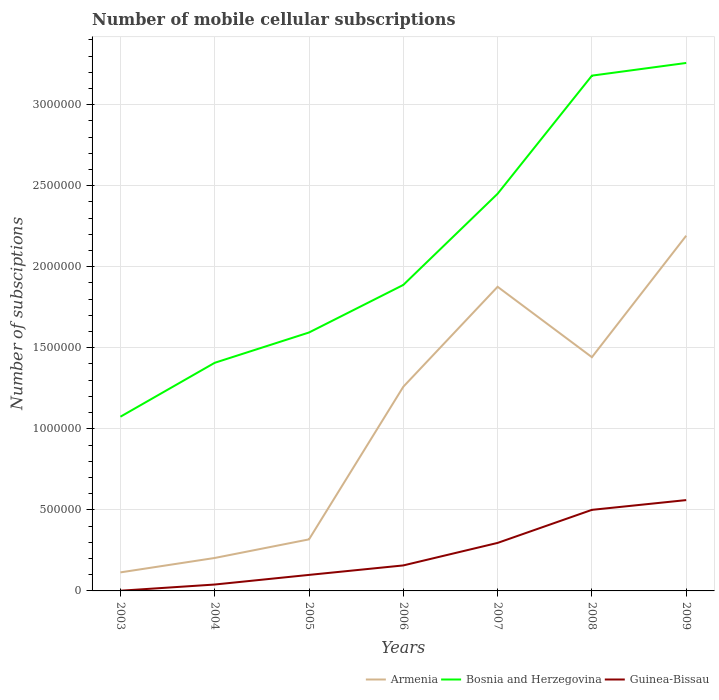How many different coloured lines are there?
Your response must be concise. 3. Does the line corresponding to Armenia intersect with the line corresponding to Guinea-Bissau?
Offer a terse response. No. Across all years, what is the maximum number of mobile cellular subscriptions in Bosnia and Herzegovina?
Your answer should be very brief. 1.07e+06. In which year was the number of mobile cellular subscriptions in Guinea-Bissau maximum?
Give a very brief answer. 2003. What is the total number of mobile cellular subscriptions in Bosnia and Herzegovina in the graph?
Ensure brevity in your answer.  -8.13e+05. What is the difference between the highest and the second highest number of mobile cellular subscriptions in Armenia?
Your response must be concise. 2.08e+06. What is the difference between two consecutive major ticks on the Y-axis?
Your response must be concise. 5.00e+05. Are the values on the major ticks of Y-axis written in scientific E-notation?
Your answer should be very brief. No. Does the graph contain any zero values?
Your answer should be compact. No. Where does the legend appear in the graph?
Keep it short and to the point. Bottom right. What is the title of the graph?
Keep it short and to the point. Number of mobile cellular subscriptions. Does "San Marino" appear as one of the legend labels in the graph?
Your answer should be very brief. No. What is the label or title of the Y-axis?
Provide a succinct answer. Number of subsciptions. What is the Number of subsciptions in Armenia in 2003?
Your answer should be very brief. 1.14e+05. What is the Number of subsciptions in Bosnia and Herzegovina in 2003?
Offer a terse response. 1.07e+06. What is the Number of subsciptions of Guinea-Bissau in 2003?
Provide a succinct answer. 1275. What is the Number of subsciptions in Armenia in 2004?
Offer a very short reply. 2.03e+05. What is the Number of subsciptions in Bosnia and Herzegovina in 2004?
Your answer should be very brief. 1.41e+06. What is the Number of subsciptions in Guinea-Bissau in 2004?
Your answer should be compact. 3.95e+04. What is the Number of subsciptions of Armenia in 2005?
Your answer should be very brief. 3.18e+05. What is the Number of subsciptions of Bosnia and Herzegovina in 2005?
Offer a terse response. 1.59e+06. What is the Number of subsciptions of Guinea-Bissau in 2005?
Make the answer very short. 9.88e+04. What is the Number of subsciptions in Armenia in 2006?
Provide a succinct answer. 1.26e+06. What is the Number of subsciptions of Bosnia and Herzegovina in 2006?
Offer a terse response. 1.89e+06. What is the Number of subsciptions in Guinea-Bissau in 2006?
Ensure brevity in your answer.  1.57e+05. What is the Number of subsciptions of Armenia in 2007?
Your response must be concise. 1.88e+06. What is the Number of subsciptions in Bosnia and Herzegovina in 2007?
Make the answer very short. 2.45e+06. What is the Number of subsciptions of Guinea-Bissau in 2007?
Provide a short and direct response. 2.96e+05. What is the Number of subsciptions of Armenia in 2008?
Provide a short and direct response. 1.44e+06. What is the Number of subsciptions in Bosnia and Herzegovina in 2008?
Provide a succinct answer. 3.18e+06. What is the Number of subsciptions of Guinea-Bissau in 2008?
Your answer should be very brief. 5.00e+05. What is the Number of subsciptions in Armenia in 2009?
Offer a terse response. 2.19e+06. What is the Number of subsciptions of Bosnia and Herzegovina in 2009?
Offer a terse response. 3.26e+06. What is the Number of subsciptions in Guinea-Bissau in 2009?
Provide a succinct answer. 5.60e+05. Across all years, what is the maximum Number of subsciptions of Armenia?
Offer a terse response. 2.19e+06. Across all years, what is the maximum Number of subsciptions in Bosnia and Herzegovina?
Provide a succinct answer. 3.26e+06. Across all years, what is the maximum Number of subsciptions in Guinea-Bissau?
Give a very brief answer. 5.60e+05. Across all years, what is the minimum Number of subsciptions in Armenia?
Your response must be concise. 1.14e+05. Across all years, what is the minimum Number of subsciptions in Bosnia and Herzegovina?
Give a very brief answer. 1.07e+06. Across all years, what is the minimum Number of subsciptions of Guinea-Bissau?
Provide a succinct answer. 1275. What is the total Number of subsciptions of Armenia in the graph?
Your answer should be compact. 7.41e+06. What is the total Number of subsciptions in Bosnia and Herzegovina in the graph?
Your response must be concise. 1.49e+07. What is the total Number of subsciptions of Guinea-Bissau in the graph?
Offer a terse response. 1.65e+06. What is the difference between the Number of subsciptions in Armenia in 2003 and that in 2004?
Your answer should be compact. -8.89e+04. What is the difference between the Number of subsciptions in Bosnia and Herzegovina in 2003 and that in 2004?
Your answer should be compact. -3.33e+05. What is the difference between the Number of subsciptions of Guinea-Bissau in 2003 and that in 2004?
Offer a very short reply. -3.82e+04. What is the difference between the Number of subsciptions in Armenia in 2003 and that in 2005?
Offer a very short reply. -2.04e+05. What is the difference between the Number of subsciptions in Bosnia and Herzegovina in 2003 and that in 2005?
Keep it short and to the point. -5.20e+05. What is the difference between the Number of subsciptions in Guinea-Bissau in 2003 and that in 2005?
Your response must be concise. -9.76e+04. What is the difference between the Number of subsciptions in Armenia in 2003 and that in 2006?
Give a very brief answer. -1.15e+06. What is the difference between the Number of subsciptions of Bosnia and Herzegovina in 2003 and that in 2006?
Offer a very short reply. -8.13e+05. What is the difference between the Number of subsciptions in Guinea-Bissau in 2003 and that in 2006?
Provide a short and direct response. -1.56e+05. What is the difference between the Number of subsciptions of Armenia in 2003 and that in 2007?
Offer a very short reply. -1.76e+06. What is the difference between the Number of subsciptions of Bosnia and Herzegovina in 2003 and that in 2007?
Provide a short and direct response. -1.38e+06. What is the difference between the Number of subsciptions of Guinea-Bissau in 2003 and that in 2007?
Your response must be concise. -2.95e+05. What is the difference between the Number of subsciptions of Armenia in 2003 and that in 2008?
Provide a succinct answer. -1.33e+06. What is the difference between the Number of subsciptions in Bosnia and Herzegovina in 2003 and that in 2008?
Make the answer very short. -2.10e+06. What is the difference between the Number of subsciptions of Guinea-Bissau in 2003 and that in 2008?
Offer a very short reply. -4.99e+05. What is the difference between the Number of subsciptions of Armenia in 2003 and that in 2009?
Keep it short and to the point. -2.08e+06. What is the difference between the Number of subsciptions of Bosnia and Herzegovina in 2003 and that in 2009?
Your answer should be compact. -2.18e+06. What is the difference between the Number of subsciptions in Guinea-Bissau in 2003 and that in 2009?
Ensure brevity in your answer.  -5.59e+05. What is the difference between the Number of subsciptions in Armenia in 2004 and that in 2005?
Your answer should be compact. -1.15e+05. What is the difference between the Number of subsciptions in Bosnia and Herzegovina in 2004 and that in 2005?
Keep it short and to the point. -1.87e+05. What is the difference between the Number of subsciptions of Guinea-Bissau in 2004 and that in 2005?
Offer a very short reply. -5.94e+04. What is the difference between the Number of subsciptions in Armenia in 2004 and that in 2006?
Provide a short and direct response. -1.06e+06. What is the difference between the Number of subsciptions of Bosnia and Herzegovina in 2004 and that in 2006?
Your answer should be compact. -4.80e+05. What is the difference between the Number of subsciptions of Guinea-Bissau in 2004 and that in 2006?
Provide a short and direct response. -1.18e+05. What is the difference between the Number of subsciptions in Armenia in 2004 and that in 2007?
Your response must be concise. -1.67e+06. What is the difference between the Number of subsciptions of Bosnia and Herzegovina in 2004 and that in 2007?
Offer a very short reply. -1.04e+06. What is the difference between the Number of subsciptions of Guinea-Bissau in 2004 and that in 2007?
Offer a terse response. -2.57e+05. What is the difference between the Number of subsciptions of Armenia in 2004 and that in 2008?
Your response must be concise. -1.24e+06. What is the difference between the Number of subsciptions in Bosnia and Herzegovina in 2004 and that in 2008?
Make the answer very short. -1.77e+06. What is the difference between the Number of subsciptions of Guinea-Bissau in 2004 and that in 2008?
Provide a succinct answer. -4.61e+05. What is the difference between the Number of subsciptions of Armenia in 2004 and that in 2009?
Your response must be concise. -1.99e+06. What is the difference between the Number of subsciptions of Bosnia and Herzegovina in 2004 and that in 2009?
Give a very brief answer. -1.85e+06. What is the difference between the Number of subsciptions of Guinea-Bissau in 2004 and that in 2009?
Give a very brief answer. -5.21e+05. What is the difference between the Number of subsciptions in Armenia in 2005 and that in 2006?
Provide a short and direct response. -9.42e+05. What is the difference between the Number of subsciptions of Bosnia and Herzegovina in 2005 and that in 2006?
Your answer should be very brief. -2.93e+05. What is the difference between the Number of subsciptions of Guinea-Bissau in 2005 and that in 2006?
Your answer should be compact. -5.85e+04. What is the difference between the Number of subsciptions of Armenia in 2005 and that in 2007?
Your answer should be compact. -1.56e+06. What is the difference between the Number of subsciptions of Bosnia and Herzegovina in 2005 and that in 2007?
Your response must be concise. -8.56e+05. What is the difference between the Number of subsciptions of Guinea-Bissau in 2005 and that in 2007?
Offer a very short reply. -1.97e+05. What is the difference between the Number of subsciptions in Armenia in 2005 and that in 2008?
Ensure brevity in your answer.  -1.12e+06. What is the difference between the Number of subsciptions of Bosnia and Herzegovina in 2005 and that in 2008?
Ensure brevity in your answer.  -1.58e+06. What is the difference between the Number of subsciptions of Guinea-Bissau in 2005 and that in 2008?
Make the answer very short. -4.01e+05. What is the difference between the Number of subsciptions of Armenia in 2005 and that in 2009?
Provide a short and direct response. -1.87e+06. What is the difference between the Number of subsciptions of Bosnia and Herzegovina in 2005 and that in 2009?
Ensure brevity in your answer.  -1.66e+06. What is the difference between the Number of subsciptions in Guinea-Bissau in 2005 and that in 2009?
Keep it short and to the point. -4.62e+05. What is the difference between the Number of subsciptions in Armenia in 2006 and that in 2007?
Offer a terse response. -6.17e+05. What is the difference between the Number of subsciptions of Bosnia and Herzegovina in 2006 and that in 2007?
Provide a short and direct response. -5.63e+05. What is the difference between the Number of subsciptions in Guinea-Bissau in 2006 and that in 2007?
Provide a short and direct response. -1.39e+05. What is the difference between the Number of subsciptions in Armenia in 2006 and that in 2008?
Your answer should be very brief. -1.82e+05. What is the difference between the Number of subsciptions of Bosnia and Herzegovina in 2006 and that in 2008?
Offer a terse response. -1.29e+06. What is the difference between the Number of subsciptions of Guinea-Bissau in 2006 and that in 2008?
Offer a terse response. -3.43e+05. What is the difference between the Number of subsciptions in Armenia in 2006 and that in 2009?
Offer a terse response. -9.32e+05. What is the difference between the Number of subsciptions of Bosnia and Herzegovina in 2006 and that in 2009?
Give a very brief answer. -1.37e+06. What is the difference between the Number of subsciptions in Guinea-Bissau in 2006 and that in 2009?
Keep it short and to the point. -4.03e+05. What is the difference between the Number of subsciptions of Armenia in 2007 and that in 2008?
Keep it short and to the point. 4.34e+05. What is the difference between the Number of subsciptions in Bosnia and Herzegovina in 2007 and that in 2008?
Provide a succinct answer. -7.29e+05. What is the difference between the Number of subsciptions of Guinea-Bissau in 2007 and that in 2008?
Make the answer very short. -2.04e+05. What is the difference between the Number of subsciptions in Armenia in 2007 and that in 2009?
Offer a terse response. -3.15e+05. What is the difference between the Number of subsciptions of Bosnia and Herzegovina in 2007 and that in 2009?
Keep it short and to the point. -8.07e+05. What is the difference between the Number of subsciptions in Guinea-Bissau in 2007 and that in 2009?
Your response must be concise. -2.64e+05. What is the difference between the Number of subsciptions of Armenia in 2008 and that in 2009?
Make the answer very short. -7.50e+05. What is the difference between the Number of subsciptions in Bosnia and Herzegovina in 2008 and that in 2009?
Provide a succinct answer. -7.82e+04. What is the difference between the Number of subsciptions in Guinea-Bissau in 2008 and that in 2009?
Ensure brevity in your answer.  -6.02e+04. What is the difference between the Number of subsciptions in Armenia in 2003 and the Number of subsciptions in Bosnia and Herzegovina in 2004?
Provide a short and direct response. -1.29e+06. What is the difference between the Number of subsciptions of Armenia in 2003 and the Number of subsciptions of Guinea-Bissau in 2004?
Provide a succinct answer. 7.49e+04. What is the difference between the Number of subsciptions in Bosnia and Herzegovina in 2003 and the Number of subsciptions in Guinea-Bissau in 2004?
Offer a terse response. 1.04e+06. What is the difference between the Number of subsciptions in Armenia in 2003 and the Number of subsciptions in Bosnia and Herzegovina in 2005?
Your answer should be compact. -1.48e+06. What is the difference between the Number of subsciptions of Armenia in 2003 and the Number of subsciptions of Guinea-Bissau in 2005?
Make the answer very short. 1.56e+04. What is the difference between the Number of subsciptions in Bosnia and Herzegovina in 2003 and the Number of subsciptions in Guinea-Bissau in 2005?
Give a very brief answer. 9.76e+05. What is the difference between the Number of subsciptions in Armenia in 2003 and the Number of subsciptions in Bosnia and Herzegovina in 2006?
Offer a terse response. -1.77e+06. What is the difference between the Number of subsciptions in Armenia in 2003 and the Number of subsciptions in Guinea-Bissau in 2006?
Your answer should be compact. -4.30e+04. What is the difference between the Number of subsciptions of Bosnia and Herzegovina in 2003 and the Number of subsciptions of Guinea-Bissau in 2006?
Keep it short and to the point. 9.17e+05. What is the difference between the Number of subsciptions in Armenia in 2003 and the Number of subsciptions in Bosnia and Herzegovina in 2007?
Provide a succinct answer. -2.34e+06. What is the difference between the Number of subsciptions in Armenia in 2003 and the Number of subsciptions in Guinea-Bissau in 2007?
Your answer should be very brief. -1.82e+05. What is the difference between the Number of subsciptions of Bosnia and Herzegovina in 2003 and the Number of subsciptions of Guinea-Bissau in 2007?
Provide a short and direct response. 7.79e+05. What is the difference between the Number of subsciptions in Armenia in 2003 and the Number of subsciptions in Bosnia and Herzegovina in 2008?
Offer a terse response. -3.06e+06. What is the difference between the Number of subsciptions in Armenia in 2003 and the Number of subsciptions in Guinea-Bissau in 2008?
Provide a short and direct response. -3.86e+05. What is the difference between the Number of subsciptions of Bosnia and Herzegovina in 2003 and the Number of subsciptions of Guinea-Bissau in 2008?
Give a very brief answer. 5.75e+05. What is the difference between the Number of subsciptions of Armenia in 2003 and the Number of subsciptions of Bosnia and Herzegovina in 2009?
Ensure brevity in your answer.  -3.14e+06. What is the difference between the Number of subsciptions in Armenia in 2003 and the Number of subsciptions in Guinea-Bissau in 2009?
Make the answer very short. -4.46e+05. What is the difference between the Number of subsciptions in Bosnia and Herzegovina in 2003 and the Number of subsciptions in Guinea-Bissau in 2009?
Your answer should be very brief. 5.14e+05. What is the difference between the Number of subsciptions in Armenia in 2004 and the Number of subsciptions in Bosnia and Herzegovina in 2005?
Give a very brief answer. -1.39e+06. What is the difference between the Number of subsciptions of Armenia in 2004 and the Number of subsciptions of Guinea-Bissau in 2005?
Your answer should be compact. 1.04e+05. What is the difference between the Number of subsciptions in Bosnia and Herzegovina in 2004 and the Number of subsciptions in Guinea-Bissau in 2005?
Your answer should be very brief. 1.31e+06. What is the difference between the Number of subsciptions of Armenia in 2004 and the Number of subsciptions of Bosnia and Herzegovina in 2006?
Your answer should be very brief. -1.68e+06. What is the difference between the Number of subsciptions in Armenia in 2004 and the Number of subsciptions in Guinea-Bissau in 2006?
Provide a short and direct response. 4.60e+04. What is the difference between the Number of subsciptions in Bosnia and Herzegovina in 2004 and the Number of subsciptions in Guinea-Bissau in 2006?
Offer a terse response. 1.25e+06. What is the difference between the Number of subsciptions of Armenia in 2004 and the Number of subsciptions of Bosnia and Herzegovina in 2007?
Keep it short and to the point. -2.25e+06. What is the difference between the Number of subsciptions of Armenia in 2004 and the Number of subsciptions of Guinea-Bissau in 2007?
Ensure brevity in your answer.  -9.29e+04. What is the difference between the Number of subsciptions in Bosnia and Herzegovina in 2004 and the Number of subsciptions in Guinea-Bissau in 2007?
Keep it short and to the point. 1.11e+06. What is the difference between the Number of subsciptions in Armenia in 2004 and the Number of subsciptions in Bosnia and Herzegovina in 2008?
Provide a succinct answer. -2.98e+06. What is the difference between the Number of subsciptions of Armenia in 2004 and the Number of subsciptions of Guinea-Bissau in 2008?
Provide a short and direct response. -2.97e+05. What is the difference between the Number of subsciptions of Bosnia and Herzegovina in 2004 and the Number of subsciptions of Guinea-Bissau in 2008?
Your answer should be very brief. 9.07e+05. What is the difference between the Number of subsciptions of Armenia in 2004 and the Number of subsciptions of Bosnia and Herzegovina in 2009?
Provide a short and direct response. -3.05e+06. What is the difference between the Number of subsciptions in Armenia in 2004 and the Number of subsciptions in Guinea-Bissau in 2009?
Offer a very short reply. -3.57e+05. What is the difference between the Number of subsciptions in Bosnia and Herzegovina in 2004 and the Number of subsciptions in Guinea-Bissau in 2009?
Make the answer very short. 8.47e+05. What is the difference between the Number of subsciptions in Armenia in 2005 and the Number of subsciptions in Bosnia and Herzegovina in 2006?
Provide a succinct answer. -1.57e+06. What is the difference between the Number of subsciptions in Armenia in 2005 and the Number of subsciptions in Guinea-Bissau in 2006?
Make the answer very short. 1.61e+05. What is the difference between the Number of subsciptions in Bosnia and Herzegovina in 2005 and the Number of subsciptions in Guinea-Bissau in 2006?
Give a very brief answer. 1.44e+06. What is the difference between the Number of subsciptions of Armenia in 2005 and the Number of subsciptions of Bosnia and Herzegovina in 2007?
Keep it short and to the point. -2.13e+06. What is the difference between the Number of subsciptions in Armenia in 2005 and the Number of subsciptions in Guinea-Bissau in 2007?
Keep it short and to the point. 2.18e+04. What is the difference between the Number of subsciptions in Bosnia and Herzegovina in 2005 and the Number of subsciptions in Guinea-Bissau in 2007?
Keep it short and to the point. 1.30e+06. What is the difference between the Number of subsciptions in Armenia in 2005 and the Number of subsciptions in Bosnia and Herzegovina in 2008?
Keep it short and to the point. -2.86e+06. What is the difference between the Number of subsciptions in Armenia in 2005 and the Number of subsciptions in Guinea-Bissau in 2008?
Your answer should be compact. -1.82e+05. What is the difference between the Number of subsciptions in Bosnia and Herzegovina in 2005 and the Number of subsciptions in Guinea-Bissau in 2008?
Your response must be concise. 1.09e+06. What is the difference between the Number of subsciptions in Armenia in 2005 and the Number of subsciptions in Bosnia and Herzegovina in 2009?
Give a very brief answer. -2.94e+06. What is the difference between the Number of subsciptions of Armenia in 2005 and the Number of subsciptions of Guinea-Bissau in 2009?
Offer a terse response. -2.42e+05. What is the difference between the Number of subsciptions in Bosnia and Herzegovina in 2005 and the Number of subsciptions in Guinea-Bissau in 2009?
Make the answer very short. 1.03e+06. What is the difference between the Number of subsciptions of Armenia in 2006 and the Number of subsciptions of Bosnia and Herzegovina in 2007?
Provide a succinct answer. -1.19e+06. What is the difference between the Number of subsciptions of Armenia in 2006 and the Number of subsciptions of Guinea-Bissau in 2007?
Provide a succinct answer. 9.64e+05. What is the difference between the Number of subsciptions of Bosnia and Herzegovina in 2006 and the Number of subsciptions of Guinea-Bissau in 2007?
Your response must be concise. 1.59e+06. What is the difference between the Number of subsciptions of Armenia in 2006 and the Number of subsciptions of Bosnia and Herzegovina in 2008?
Keep it short and to the point. -1.92e+06. What is the difference between the Number of subsciptions in Armenia in 2006 and the Number of subsciptions in Guinea-Bissau in 2008?
Ensure brevity in your answer.  7.60e+05. What is the difference between the Number of subsciptions of Bosnia and Herzegovina in 2006 and the Number of subsciptions of Guinea-Bissau in 2008?
Offer a terse response. 1.39e+06. What is the difference between the Number of subsciptions of Armenia in 2006 and the Number of subsciptions of Bosnia and Herzegovina in 2009?
Your answer should be compact. -2.00e+06. What is the difference between the Number of subsciptions in Armenia in 2006 and the Number of subsciptions in Guinea-Bissau in 2009?
Ensure brevity in your answer.  6.99e+05. What is the difference between the Number of subsciptions in Bosnia and Herzegovina in 2006 and the Number of subsciptions in Guinea-Bissau in 2009?
Provide a succinct answer. 1.33e+06. What is the difference between the Number of subsciptions in Armenia in 2007 and the Number of subsciptions in Bosnia and Herzegovina in 2008?
Make the answer very short. -1.30e+06. What is the difference between the Number of subsciptions in Armenia in 2007 and the Number of subsciptions in Guinea-Bissau in 2008?
Offer a terse response. 1.38e+06. What is the difference between the Number of subsciptions of Bosnia and Herzegovina in 2007 and the Number of subsciptions of Guinea-Bissau in 2008?
Ensure brevity in your answer.  1.95e+06. What is the difference between the Number of subsciptions in Armenia in 2007 and the Number of subsciptions in Bosnia and Herzegovina in 2009?
Keep it short and to the point. -1.38e+06. What is the difference between the Number of subsciptions in Armenia in 2007 and the Number of subsciptions in Guinea-Bissau in 2009?
Your answer should be compact. 1.32e+06. What is the difference between the Number of subsciptions in Bosnia and Herzegovina in 2007 and the Number of subsciptions in Guinea-Bissau in 2009?
Your answer should be very brief. 1.89e+06. What is the difference between the Number of subsciptions in Armenia in 2008 and the Number of subsciptions in Bosnia and Herzegovina in 2009?
Make the answer very short. -1.82e+06. What is the difference between the Number of subsciptions in Armenia in 2008 and the Number of subsciptions in Guinea-Bissau in 2009?
Offer a very short reply. 8.82e+05. What is the difference between the Number of subsciptions in Bosnia and Herzegovina in 2008 and the Number of subsciptions in Guinea-Bissau in 2009?
Your answer should be very brief. 2.62e+06. What is the average Number of subsciptions of Armenia per year?
Offer a very short reply. 1.06e+06. What is the average Number of subsciptions in Bosnia and Herzegovina per year?
Make the answer very short. 2.12e+06. What is the average Number of subsciptions of Guinea-Bissau per year?
Your answer should be compact. 2.36e+05. In the year 2003, what is the difference between the Number of subsciptions of Armenia and Number of subsciptions of Bosnia and Herzegovina?
Your response must be concise. -9.60e+05. In the year 2003, what is the difference between the Number of subsciptions in Armenia and Number of subsciptions in Guinea-Bissau?
Make the answer very short. 1.13e+05. In the year 2003, what is the difference between the Number of subsciptions of Bosnia and Herzegovina and Number of subsciptions of Guinea-Bissau?
Offer a terse response. 1.07e+06. In the year 2004, what is the difference between the Number of subsciptions in Armenia and Number of subsciptions in Bosnia and Herzegovina?
Keep it short and to the point. -1.20e+06. In the year 2004, what is the difference between the Number of subsciptions in Armenia and Number of subsciptions in Guinea-Bissau?
Your answer should be compact. 1.64e+05. In the year 2004, what is the difference between the Number of subsciptions in Bosnia and Herzegovina and Number of subsciptions in Guinea-Bissau?
Make the answer very short. 1.37e+06. In the year 2005, what is the difference between the Number of subsciptions in Armenia and Number of subsciptions in Bosnia and Herzegovina?
Ensure brevity in your answer.  -1.28e+06. In the year 2005, what is the difference between the Number of subsciptions in Armenia and Number of subsciptions in Guinea-Bissau?
Your response must be concise. 2.19e+05. In the year 2005, what is the difference between the Number of subsciptions in Bosnia and Herzegovina and Number of subsciptions in Guinea-Bissau?
Provide a succinct answer. 1.50e+06. In the year 2006, what is the difference between the Number of subsciptions in Armenia and Number of subsciptions in Bosnia and Herzegovina?
Provide a short and direct response. -6.28e+05. In the year 2006, what is the difference between the Number of subsciptions in Armenia and Number of subsciptions in Guinea-Bissau?
Offer a very short reply. 1.10e+06. In the year 2006, what is the difference between the Number of subsciptions in Bosnia and Herzegovina and Number of subsciptions in Guinea-Bissau?
Provide a succinct answer. 1.73e+06. In the year 2007, what is the difference between the Number of subsciptions of Armenia and Number of subsciptions of Bosnia and Herzegovina?
Your answer should be compact. -5.74e+05. In the year 2007, what is the difference between the Number of subsciptions in Armenia and Number of subsciptions in Guinea-Bissau?
Make the answer very short. 1.58e+06. In the year 2007, what is the difference between the Number of subsciptions in Bosnia and Herzegovina and Number of subsciptions in Guinea-Bissau?
Make the answer very short. 2.15e+06. In the year 2008, what is the difference between the Number of subsciptions in Armenia and Number of subsciptions in Bosnia and Herzegovina?
Your answer should be very brief. -1.74e+06. In the year 2008, what is the difference between the Number of subsciptions of Armenia and Number of subsciptions of Guinea-Bissau?
Give a very brief answer. 9.42e+05. In the year 2008, what is the difference between the Number of subsciptions in Bosnia and Herzegovina and Number of subsciptions in Guinea-Bissau?
Offer a terse response. 2.68e+06. In the year 2009, what is the difference between the Number of subsciptions of Armenia and Number of subsciptions of Bosnia and Herzegovina?
Make the answer very short. -1.07e+06. In the year 2009, what is the difference between the Number of subsciptions of Armenia and Number of subsciptions of Guinea-Bissau?
Offer a terse response. 1.63e+06. In the year 2009, what is the difference between the Number of subsciptions of Bosnia and Herzegovina and Number of subsciptions of Guinea-Bissau?
Give a very brief answer. 2.70e+06. What is the ratio of the Number of subsciptions in Armenia in 2003 to that in 2004?
Offer a terse response. 0.56. What is the ratio of the Number of subsciptions in Bosnia and Herzegovina in 2003 to that in 2004?
Give a very brief answer. 0.76. What is the ratio of the Number of subsciptions of Guinea-Bissau in 2003 to that in 2004?
Your response must be concise. 0.03. What is the ratio of the Number of subsciptions in Armenia in 2003 to that in 2005?
Keep it short and to the point. 0.36. What is the ratio of the Number of subsciptions of Bosnia and Herzegovina in 2003 to that in 2005?
Provide a succinct answer. 0.67. What is the ratio of the Number of subsciptions of Guinea-Bissau in 2003 to that in 2005?
Offer a very short reply. 0.01. What is the ratio of the Number of subsciptions in Armenia in 2003 to that in 2006?
Provide a short and direct response. 0.09. What is the ratio of the Number of subsciptions in Bosnia and Herzegovina in 2003 to that in 2006?
Your answer should be very brief. 0.57. What is the ratio of the Number of subsciptions in Guinea-Bissau in 2003 to that in 2006?
Your answer should be compact. 0.01. What is the ratio of the Number of subsciptions in Armenia in 2003 to that in 2007?
Provide a succinct answer. 0.06. What is the ratio of the Number of subsciptions of Bosnia and Herzegovina in 2003 to that in 2007?
Ensure brevity in your answer.  0.44. What is the ratio of the Number of subsciptions of Guinea-Bissau in 2003 to that in 2007?
Offer a terse response. 0. What is the ratio of the Number of subsciptions of Armenia in 2003 to that in 2008?
Provide a short and direct response. 0.08. What is the ratio of the Number of subsciptions in Bosnia and Herzegovina in 2003 to that in 2008?
Provide a short and direct response. 0.34. What is the ratio of the Number of subsciptions in Guinea-Bissau in 2003 to that in 2008?
Your answer should be very brief. 0. What is the ratio of the Number of subsciptions of Armenia in 2003 to that in 2009?
Offer a terse response. 0.05. What is the ratio of the Number of subsciptions in Bosnia and Herzegovina in 2003 to that in 2009?
Keep it short and to the point. 0.33. What is the ratio of the Number of subsciptions of Guinea-Bissau in 2003 to that in 2009?
Give a very brief answer. 0. What is the ratio of the Number of subsciptions in Armenia in 2004 to that in 2005?
Make the answer very short. 0.64. What is the ratio of the Number of subsciptions of Bosnia and Herzegovina in 2004 to that in 2005?
Provide a succinct answer. 0.88. What is the ratio of the Number of subsciptions in Guinea-Bissau in 2004 to that in 2005?
Offer a terse response. 0.4. What is the ratio of the Number of subsciptions in Armenia in 2004 to that in 2006?
Ensure brevity in your answer.  0.16. What is the ratio of the Number of subsciptions in Bosnia and Herzegovina in 2004 to that in 2006?
Make the answer very short. 0.75. What is the ratio of the Number of subsciptions in Guinea-Bissau in 2004 to that in 2006?
Provide a succinct answer. 0.25. What is the ratio of the Number of subsciptions of Armenia in 2004 to that in 2007?
Provide a succinct answer. 0.11. What is the ratio of the Number of subsciptions of Bosnia and Herzegovina in 2004 to that in 2007?
Your answer should be very brief. 0.57. What is the ratio of the Number of subsciptions in Guinea-Bissau in 2004 to that in 2007?
Offer a very short reply. 0.13. What is the ratio of the Number of subsciptions of Armenia in 2004 to that in 2008?
Provide a succinct answer. 0.14. What is the ratio of the Number of subsciptions in Bosnia and Herzegovina in 2004 to that in 2008?
Provide a short and direct response. 0.44. What is the ratio of the Number of subsciptions of Guinea-Bissau in 2004 to that in 2008?
Ensure brevity in your answer.  0.08. What is the ratio of the Number of subsciptions of Armenia in 2004 to that in 2009?
Your answer should be compact. 0.09. What is the ratio of the Number of subsciptions in Bosnia and Herzegovina in 2004 to that in 2009?
Make the answer very short. 0.43. What is the ratio of the Number of subsciptions of Guinea-Bissau in 2004 to that in 2009?
Your answer should be compact. 0.07. What is the ratio of the Number of subsciptions in Armenia in 2005 to that in 2006?
Your response must be concise. 0.25. What is the ratio of the Number of subsciptions of Bosnia and Herzegovina in 2005 to that in 2006?
Make the answer very short. 0.84. What is the ratio of the Number of subsciptions in Guinea-Bissau in 2005 to that in 2006?
Your answer should be very brief. 0.63. What is the ratio of the Number of subsciptions in Armenia in 2005 to that in 2007?
Offer a terse response. 0.17. What is the ratio of the Number of subsciptions in Bosnia and Herzegovina in 2005 to that in 2007?
Offer a terse response. 0.65. What is the ratio of the Number of subsciptions in Guinea-Bissau in 2005 to that in 2007?
Offer a terse response. 0.33. What is the ratio of the Number of subsciptions of Armenia in 2005 to that in 2008?
Provide a succinct answer. 0.22. What is the ratio of the Number of subsciptions in Bosnia and Herzegovina in 2005 to that in 2008?
Keep it short and to the point. 0.5. What is the ratio of the Number of subsciptions in Guinea-Bissau in 2005 to that in 2008?
Make the answer very short. 0.2. What is the ratio of the Number of subsciptions in Armenia in 2005 to that in 2009?
Provide a short and direct response. 0.15. What is the ratio of the Number of subsciptions in Bosnia and Herzegovina in 2005 to that in 2009?
Offer a very short reply. 0.49. What is the ratio of the Number of subsciptions in Guinea-Bissau in 2005 to that in 2009?
Give a very brief answer. 0.18. What is the ratio of the Number of subsciptions of Armenia in 2006 to that in 2007?
Offer a terse response. 0.67. What is the ratio of the Number of subsciptions of Bosnia and Herzegovina in 2006 to that in 2007?
Ensure brevity in your answer.  0.77. What is the ratio of the Number of subsciptions in Guinea-Bissau in 2006 to that in 2007?
Your answer should be compact. 0.53. What is the ratio of the Number of subsciptions of Armenia in 2006 to that in 2008?
Your response must be concise. 0.87. What is the ratio of the Number of subsciptions in Bosnia and Herzegovina in 2006 to that in 2008?
Provide a short and direct response. 0.59. What is the ratio of the Number of subsciptions in Guinea-Bissau in 2006 to that in 2008?
Your answer should be compact. 0.31. What is the ratio of the Number of subsciptions in Armenia in 2006 to that in 2009?
Ensure brevity in your answer.  0.57. What is the ratio of the Number of subsciptions in Bosnia and Herzegovina in 2006 to that in 2009?
Give a very brief answer. 0.58. What is the ratio of the Number of subsciptions of Guinea-Bissau in 2006 to that in 2009?
Provide a succinct answer. 0.28. What is the ratio of the Number of subsciptions of Armenia in 2007 to that in 2008?
Ensure brevity in your answer.  1.3. What is the ratio of the Number of subsciptions in Bosnia and Herzegovina in 2007 to that in 2008?
Keep it short and to the point. 0.77. What is the ratio of the Number of subsciptions in Guinea-Bissau in 2007 to that in 2008?
Give a very brief answer. 0.59. What is the ratio of the Number of subsciptions of Armenia in 2007 to that in 2009?
Provide a succinct answer. 0.86. What is the ratio of the Number of subsciptions of Bosnia and Herzegovina in 2007 to that in 2009?
Offer a very short reply. 0.75. What is the ratio of the Number of subsciptions in Guinea-Bissau in 2007 to that in 2009?
Ensure brevity in your answer.  0.53. What is the ratio of the Number of subsciptions of Armenia in 2008 to that in 2009?
Your answer should be compact. 0.66. What is the ratio of the Number of subsciptions in Bosnia and Herzegovina in 2008 to that in 2009?
Keep it short and to the point. 0.98. What is the ratio of the Number of subsciptions of Guinea-Bissau in 2008 to that in 2009?
Provide a short and direct response. 0.89. What is the difference between the highest and the second highest Number of subsciptions of Armenia?
Provide a succinct answer. 3.15e+05. What is the difference between the highest and the second highest Number of subsciptions in Bosnia and Herzegovina?
Provide a succinct answer. 7.82e+04. What is the difference between the highest and the second highest Number of subsciptions of Guinea-Bissau?
Provide a succinct answer. 6.02e+04. What is the difference between the highest and the lowest Number of subsciptions of Armenia?
Make the answer very short. 2.08e+06. What is the difference between the highest and the lowest Number of subsciptions in Bosnia and Herzegovina?
Provide a short and direct response. 2.18e+06. What is the difference between the highest and the lowest Number of subsciptions of Guinea-Bissau?
Keep it short and to the point. 5.59e+05. 